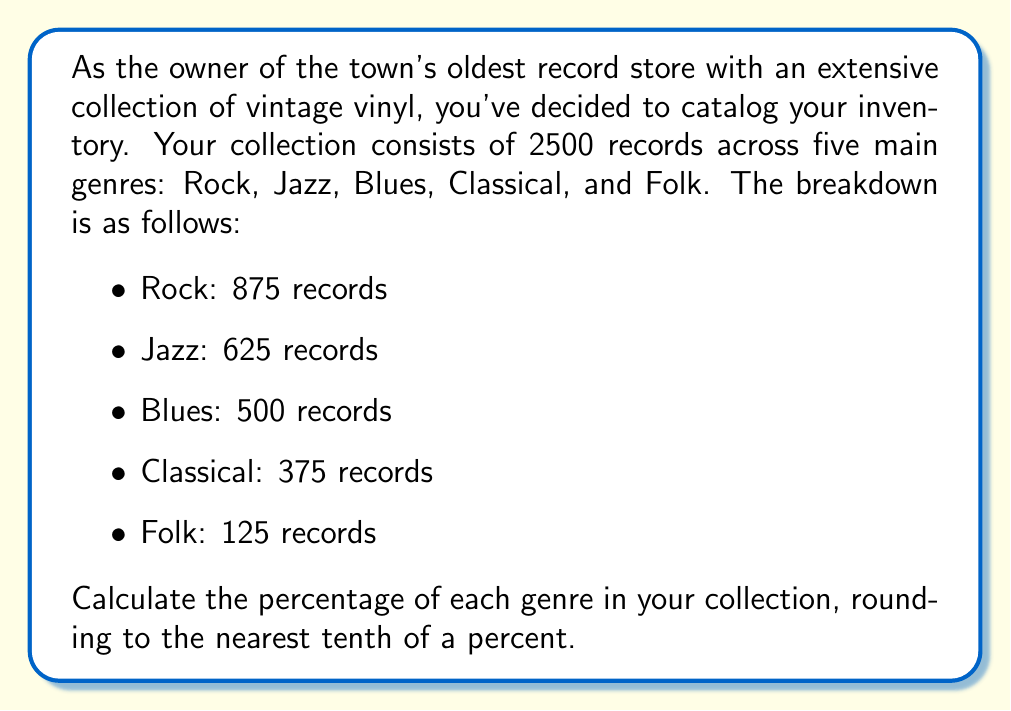What is the answer to this math problem? To calculate the percentage of each genre in the collection, we need to divide the number of records in each genre by the total number of records and then multiply by 100. Let's go through this step-by-step:

1. Total number of records: 2500

2. For each genre:
   
   a) Rock:
   $$\frac{875}{2500} \times 100 = 35\%$$
   
   b) Jazz:
   $$\frac{625}{2500} \times 100 = 25\%$$
   
   c) Blues:
   $$\frac{500}{2500} \times 100 = 20\%$$
   
   d) Classical:
   $$\frac{375}{2500} \times 100 = 15\%$$
   
   e) Folk:
   $$\frac{125}{2500} \times 100 = 5\%$$

3. Rounding to the nearest tenth of a percent:
   All of these percentages are already whole numbers, so no further rounding is necessary.

4. Verification:
   Let's sum up all percentages to ensure they add up to 100%:
   $$35\% + 25\% + 20\% + 15\% + 5\% = 100\%$$

This confirms our calculations are correct.
Answer: The percentages of each genre in the collection are:
Rock: 35.0%
Jazz: 25.0%
Blues: 20.0%
Classical: 15.0%
Folk: 5.0% 